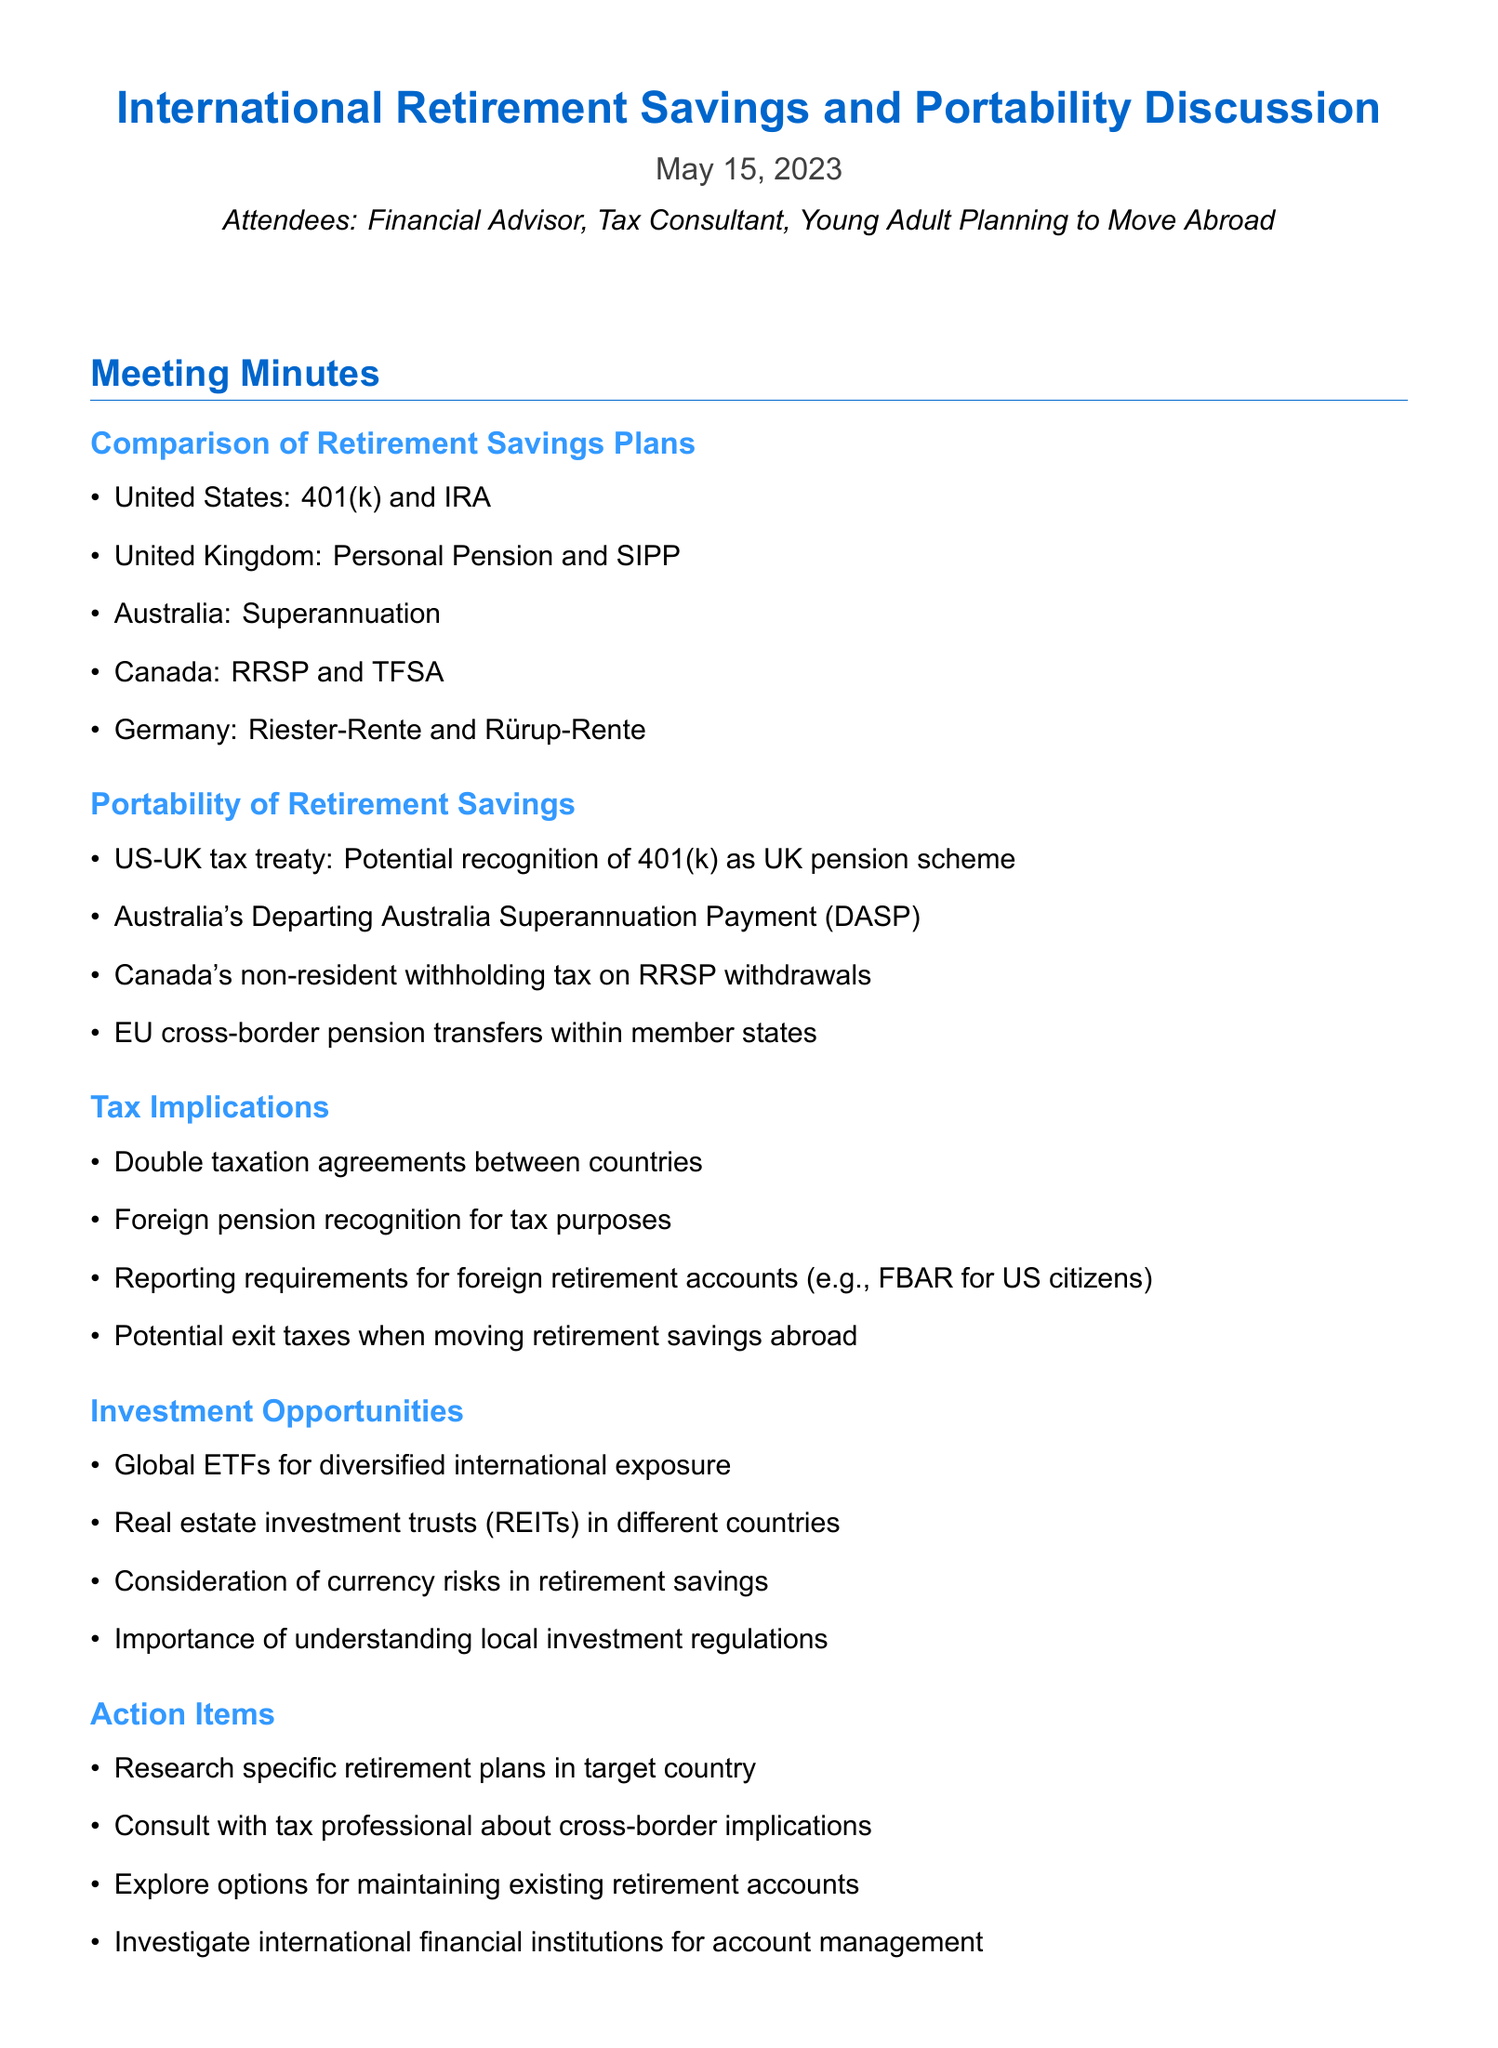what is the meeting title? The meeting title is mentioned in the document, which is the International Retirement Savings and Portability Discussion.
Answer: International Retirement Savings and Portability Discussion who attended the meeting? The attendees are listed in the document, including a Financial Advisor, Tax Consultant, and a Young Adult Planning to Move Abroad.
Answer: Financial Advisor, Tax Consultant, Young Adult Planning to Move Abroad what type of retirement plan is referenced for Canada? The document specifies the types of retirement plans available in Canada, which include RRSP and TFSA.
Answer: RRSP and TFSA what is one implication of the US-UK tax treaty mentioned? The document mentions the potential recognition of the 401(k) as a UK pension scheme under the US-UK tax treaty.
Answer: Potential recognition of 401(k) as UK pension scheme what are global ETFs? The document references global ETFs in the context of investment opportunities, indicating they provide diversified international exposure.
Answer: Diversified international exposure how many action items are listed in the document? There are four action items mentioned in the document under the Action Items section.
Answer: Four what tax consideration is mentioned for foreign retirement accounts? The document highlights the reporting requirements for foreign retirement accounts as a key tax consideration.
Answer: Reporting requirements what does DASP stand for in relation to Australia? The acronym DASP is explained in the context of Australia's retirement savings portability, specifically as Departing Australia Superannuation Payment.
Answer: Departing Australia Superannuation Payment how is the structure of this document organized? The structure is organized into sections that compare retirement plans, discuss portability, tax implications, investment opportunities, and action items.
Answer: Sections on retirement plans, portability, tax implications, investment opportunities, and action items 